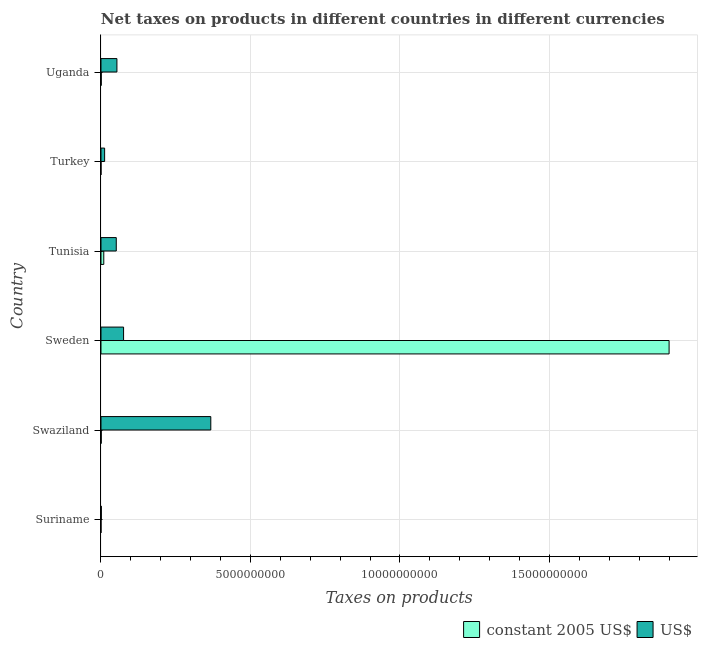How many different coloured bars are there?
Offer a very short reply. 2. Are the number of bars on each tick of the Y-axis equal?
Provide a short and direct response. Yes. How many bars are there on the 5th tick from the top?
Offer a terse response. 2. What is the label of the 1st group of bars from the top?
Provide a succinct answer. Uganda. What is the net taxes in us$ in Suriname?
Offer a terse response. 1.12e+07. Across all countries, what is the maximum net taxes in us$?
Make the answer very short. 3.67e+09. Across all countries, what is the minimum net taxes in us$?
Keep it short and to the point. 1.12e+07. In which country was the net taxes in constant 2005 us$ maximum?
Provide a succinct answer. Sweden. In which country was the net taxes in constant 2005 us$ minimum?
Your response must be concise. Turkey. What is the total net taxes in us$ in the graph?
Offer a very short reply. 5.61e+09. What is the difference between the net taxes in us$ in Suriname and that in Swaziland?
Give a very brief answer. -3.66e+09. What is the difference between the net taxes in us$ in Turkey and the net taxes in constant 2005 us$ in Sweden?
Offer a very short reply. -1.89e+1. What is the average net taxes in constant 2005 us$ per country?
Offer a terse response. 3.19e+09. What is the difference between the net taxes in us$ and net taxes in constant 2005 us$ in Suriname?
Provide a succinct answer. 1.12e+07. What is the ratio of the net taxes in constant 2005 us$ in Suriname to that in Sweden?
Provide a short and direct response. 0. Is the difference between the net taxes in constant 2005 us$ in Suriname and Turkey greater than the difference between the net taxes in us$ in Suriname and Turkey?
Provide a short and direct response. Yes. What is the difference between the highest and the second highest net taxes in us$?
Give a very brief answer. 2.92e+09. What is the difference between the highest and the lowest net taxes in constant 2005 us$?
Your response must be concise. 1.90e+1. Is the sum of the net taxes in us$ in Sweden and Uganda greater than the maximum net taxes in constant 2005 us$ across all countries?
Provide a succinct answer. No. What does the 2nd bar from the top in Uganda represents?
Your answer should be compact. Constant 2005 us$. What does the 1st bar from the bottom in Sweden represents?
Provide a short and direct response. Constant 2005 us$. How many bars are there?
Give a very brief answer. 12. Are all the bars in the graph horizontal?
Offer a very short reply. Yes. How many countries are there in the graph?
Provide a short and direct response. 6. What is the difference between two consecutive major ticks on the X-axis?
Your response must be concise. 5.00e+09. Does the graph contain any zero values?
Your response must be concise. No. Where does the legend appear in the graph?
Offer a terse response. Bottom right. What is the title of the graph?
Provide a succinct answer. Net taxes on products in different countries in different currencies. Does "Lowest 20% of population" appear as one of the legend labels in the graph?
Offer a very short reply. No. What is the label or title of the X-axis?
Your answer should be very brief. Taxes on products. What is the label or title of the Y-axis?
Make the answer very short. Country. What is the Taxes on products in constant 2005 US$ in Suriname?
Your answer should be very brief. 6000. What is the Taxes on products of US$ in Suriname?
Make the answer very short. 1.12e+07. What is the Taxes on products of US$ in Swaziland?
Your response must be concise. 3.67e+09. What is the Taxes on products of constant 2005 US$ in Sweden?
Offer a terse response. 1.90e+1. What is the Taxes on products in US$ in Sweden?
Give a very brief answer. 7.55e+08. What is the Taxes on products of constant 2005 US$ in Tunisia?
Keep it short and to the point. 9.32e+07. What is the Taxes on products in US$ in Tunisia?
Keep it short and to the point. 5.11e+08. What is the Taxes on products in constant 2005 US$ in Turkey?
Ensure brevity in your answer.  4600. What is the Taxes on products in US$ in Turkey?
Provide a succinct answer. 1.22e+08. What is the Taxes on products in constant 2005 US$ in Uganda?
Keep it short and to the point. 8.68e+06. What is the Taxes on products of US$ in Uganda?
Keep it short and to the point. 5.33e+08. Across all countries, what is the maximum Taxes on products of constant 2005 US$?
Your answer should be very brief. 1.90e+1. Across all countries, what is the maximum Taxes on products of US$?
Offer a terse response. 3.67e+09. Across all countries, what is the minimum Taxes on products of constant 2005 US$?
Make the answer very short. 4600. Across all countries, what is the minimum Taxes on products of US$?
Provide a succinct answer. 1.12e+07. What is the total Taxes on products in constant 2005 US$ in the graph?
Give a very brief answer. 1.91e+1. What is the total Taxes on products of US$ in the graph?
Keep it short and to the point. 5.61e+09. What is the difference between the Taxes on products in constant 2005 US$ in Suriname and that in Swaziland?
Give a very brief answer. -7.99e+06. What is the difference between the Taxes on products of US$ in Suriname and that in Swaziland?
Provide a succinct answer. -3.66e+09. What is the difference between the Taxes on products in constant 2005 US$ in Suriname and that in Sweden?
Keep it short and to the point. -1.90e+1. What is the difference between the Taxes on products of US$ in Suriname and that in Sweden?
Your response must be concise. -7.44e+08. What is the difference between the Taxes on products of constant 2005 US$ in Suriname and that in Tunisia?
Make the answer very short. -9.32e+07. What is the difference between the Taxes on products in US$ in Suriname and that in Tunisia?
Give a very brief answer. -5.00e+08. What is the difference between the Taxes on products of constant 2005 US$ in Suriname and that in Turkey?
Offer a very short reply. 1400. What is the difference between the Taxes on products of US$ in Suriname and that in Turkey?
Provide a short and direct response. -1.10e+08. What is the difference between the Taxes on products of constant 2005 US$ in Suriname and that in Uganda?
Keep it short and to the point. -8.67e+06. What is the difference between the Taxes on products in US$ in Suriname and that in Uganda?
Your response must be concise. -5.22e+08. What is the difference between the Taxes on products in constant 2005 US$ in Swaziland and that in Sweden?
Offer a terse response. -1.90e+1. What is the difference between the Taxes on products of US$ in Swaziland and that in Sweden?
Your response must be concise. 2.92e+09. What is the difference between the Taxes on products of constant 2005 US$ in Swaziland and that in Tunisia?
Give a very brief answer. -8.52e+07. What is the difference between the Taxes on products in US$ in Swaziland and that in Tunisia?
Give a very brief answer. 3.16e+09. What is the difference between the Taxes on products in constant 2005 US$ in Swaziland and that in Turkey?
Provide a short and direct response. 8.00e+06. What is the difference between the Taxes on products of US$ in Swaziland and that in Turkey?
Keep it short and to the point. 3.55e+09. What is the difference between the Taxes on products of constant 2005 US$ in Swaziland and that in Uganda?
Your response must be concise. -6.80e+05. What is the difference between the Taxes on products in US$ in Swaziland and that in Uganda?
Provide a short and direct response. 3.14e+09. What is the difference between the Taxes on products of constant 2005 US$ in Sweden and that in Tunisia?
Your response must be concise. 1.89e+1. What is the difference between the Taxes on products in US$ in Sweden and that in Tunisia?
Provide a short and direct response. 2.44e+08. What is the difference between the Taxes on products in constant 2005 US$ in Sweden and that in Turkey?
Your response must be concise. 1.90e+1. What is the difference between the Taxes on products in US$ in Sweden and that in Turkey?
Offer a terse response. 6.34e+08. What is the difference between the Taxes on products of constant 2005 US$ in Sweden and that in Uganda?
Your response must be concise. 1.90e+1. What is the difference between the Taxes on products in US$ in Sweden and that in Uganda?
Provide a short and direct response. 2.23e+08. What is the difference between the Taxes on products of constant 2005 US$ in Tunisia and that in Turkey?
Your response must be concise. 9.32e+07. What is the difference between the Taxes on products in US$ in Tunisia and that in Turkey?
Ensure brevity in your answer.  3.90e+08. What is the difference between the Taxes on products of constant 2005 US$ in Tunisia and that in Uganda?
Ensure brevity in your answer.  8.45e+07. What is the difference between the Taxes on products of US$ in Tunisia and that in Uganda?
Your answer should be compact. -2.17e+07. What is the difference between the Taxes on products in constant 2005 US$ in Turkey and that in Uganda?
Provide a succinct answer. -8.68e+06. What is the difference between the Taxes on products in US$ in Turkey and that in Uganda?
Your answer should be compact. -4.11e+08. What is the difference between the Taxes on products of constant 2005 US$ in Suriname and the Taxes on products of US$ in Swaziland?
Your response must be concise. -3.67e+09. What is the difference between the Taxes on products of constant 2005 US$ in Suriname and the Taxes on products of US$ in Sweden?
Your answer should be compact. -7.55e+08. What is the difference between the Taxes on products of constant 2005 US$ in Suriname and the Taxes on products of US$ in Tunisia?
Offer a terse response. -5.11e+08. What is the difference between the Taxes on products in constant 2005 US$ in Suriname and the Taxes on products in US$ in Turkey?
Ensure brevity in your answer.  -1.22e+08. What is the difference between the Taxes on products of constant 2005 US$ in Suriname and the Taxes on products of US$ in Uganda?
Provide a short and direct response. -5.33e+08. What is the difference between the Taxes on products of constant 2005 US$ in Swaziland and the Taxes on products of US$ in Sweden?
Offer a terse response. -7.47e+08. What is the difference between the Taxes on products of constant 2005 US$ in Swaziland and the Taxes on products of US$ in Tunisia?
Your response must be concise. -5.03e+08. What is the difference between the Taxes on products of constant 2005 US$ in Swaziland and the Taxes on products of US$ in Turkey?
Offer a very short reply. -1.14e+08. What is the difference between the Taxes on products in constant 2005 US$ in Swaziland and the Taxes on products in US$ in Uganda?
Provide a short and direct response. -5.25e+08. What is the difference between the Taxes on products in constant 2005 US$ in Sweden and the Taxes on products in US$ in Tunisia?
Ensure brevity in your answer.  1.85e+1. What is the difference between the Taxes on products of constant 2005 US$ in Sweden and the Taxes on products of US$ in Turkey?
Offer a terse response. 1.89e+1. What is the difference between the Taxes on products in constant 2005 US$ in Sweden and the Taxes on products in US$ in Uganda?
Ensure brevity in your answer.  1.85e+1. What is the difference between the Taxes on products of constant 2005 US$ in Tunisia and the Taxes on products of US$ in Turkey?
Offer a terse response. -2.83e+07. What is the difference between the Taxes on products of constant 2005 US$ in Tunisia and the Taxes on products of US$ in Uganda?
Provide a short and direct response. -4.40e+08. What is the difference between the Taxes on products of constant 2005 US$ in Turkey and the Taxes on products of US$ in Uganda?
Give a very brief answer. -5.33e+08. What is the average Taxes on products of constant 2005 US$ per country?
Your response must be concise. 3.19e+09. What is the average Taxes on products in US$ per country?
Your response must be concise. 9.34e+08. What is the difference between the Taxes on products of constant 2005 US$ and Taxes on products of US$ in Suriname?
Give a very brief answer. -1.12e+07. What is the difference between the Taxes on products of constant 2005 US$ and Taxes on products of US$ in Swaziland?
Offer a terse response. -3.67e+09. What is the difference between the Taxes on products in constant 2005 US$ and Taxes on products in US$ in Sweden?
Your answer should be compact. 1.82e+1. What is the difference between the Taxes on products of constant 2005 US$ and Taxes on products of US$ in Tunisia?
Give a very brief answer. -4.18e+08. What is the difference between the Taxes on products in constant 2005 US$ and Taxes on products in US$ in Turkey?
Provide a succinct answer. -1.22e+08. What is the difference between the Taxes on products in constant 2005 US$ and Taxes on products in US$ in Uganda?
Your response must be concise. -5.24e+08. What is the ratio of the Taxes on products of constant 2005 US$ in Suriname to that in Swaziland?
Provide a short and direct response. 0. What is the ratio of the Taxes on products in US$ in Suriname to that in Swaziland?
Your answer should be compact. 0. What is the ratio of the Taxes on products in constant 2005 US$ in Suriname to that in Sweden?
Ensure brevity in your answer.  0. What is the ratio of the Taxes on products in US$ in Suriname to that in Sweden?
Ensure brevity in your answer.  0.01. What is the ratio of the Taxes on products in US$ in Suriname to that in Tunisia?
Ensure brevity in your answer.  0.02. What is the ratio of the Taxes on products of constant 2005 US$ in Suriname to that in Turkey?
Your answer should be very brief. 1.3. What is the ratio of the Taxes on products of US$ in Suriname to that in Turkey?
Ensure brevity in your answer.  0.09. What is the ratio of the Taxes on products in constant 2005 US$ in Suriname to that in Uganda?
Make the answer very short. 0. What is the ratio of the Taxes on products in US$ in Suriname to that in Uganda?
Offer a very short reply. 0.02. What is the ratio of the Taxes on products in constant 2005 US$ in Swaziland to that in Sweden?
Ensure brevity in your answer.  0. What is the ratio of the Taxes on products in US$ in Swaziland to that in Sweden?
Offer a very short reply. 4.86. What is the ratio of the Taxes on products in constant 2005 US$ in Swaziland to that in Tunisia?
Make the answer very short. 0.09. What is the ratio of the Taxes on products in US$ in Swaziland to that in Tunisia?
Keep it short and to the point. 7.19. What is the ratio of the Taxes on products in constant 2005 US$ in Swaziland to that in Turkey?
Your answer should be very brief. 1739.13. What is the ratio of the Taxes on products in US$ in Swaziland to that in Turkey?
Your answer should be compact. 30.23. What is the ratio of the Taxes on products in constant 2005 US$ in Swaziland to that in Uganda?
Your answer should be very brief. 0.92. What is the ratio of the Taxes on products of US$ in Swaziland to that in Uganda?
Ensure brevity in your answer.  6.89. What is the ratio of the Taxes on products of constant 2005 US$ in Sweden to that in Tunisia?
Provide a short and direct response. 203.88. What is the ratio of the Taxes on products of US$ in Sweden to that in Tunisia?
Provide a short and direct response. 1.48. What is the ratio of the Taxes on products of constant 2005 US$ in Sweden to that in Turkey?
Provide a short and direct response. 4.13e+06. What is the ratio of the Taxes on products of US$ in Sweden to that in Turkey?
Make the answer very short. 6.22. What is the ratio of the Taxes on products of constant 2005 US$ in Sweden to that in Uganda?
Your answer should be compact. 2189.1. What is the ratio of the Taxes on products of US$ in Sweden to that in Uganda?
Keep it short and to the point. 1.42. What is the ratio of the Taxes on products of constant 2005 US$ in Tunisia to that in Turkey?
Keep it short and to the point. 2.03e+04. What is the ratio of the Taxes on products in US$ in Tunisia to that in Turkey?
Your response must be concise. 4.21. What is the ratio of the Taxes on products in constant 2005 US$ in Tunisia to that in Uganda?
Ensure brevity in your answer.  10.74. What is the ratio of the Taxes on products in US$ in Tunisia to that in Uganda?
Give a very brief answer. 0.96. What is the ratio of the Taxes on products in US$ in Turkey to that in Uganda?
Your answer should be compact. 0.23. What is the difference between the highest and the second highest Taxes on products of constant 2005 US$?
Make the answer very short. 1.89e+1. What is the difference between the highest and the second highest Taxes on products of US$?
Offer a terse response. 2.92e+09. What is the difference between the highest and the lowest Taxes on products of constant 2005 US$?
Give a very brief answer. 1.90e+1. What is the difference between the highest and the lowest Taxes on products of US$?
Keep it short and to the point. 3.66e+09. 